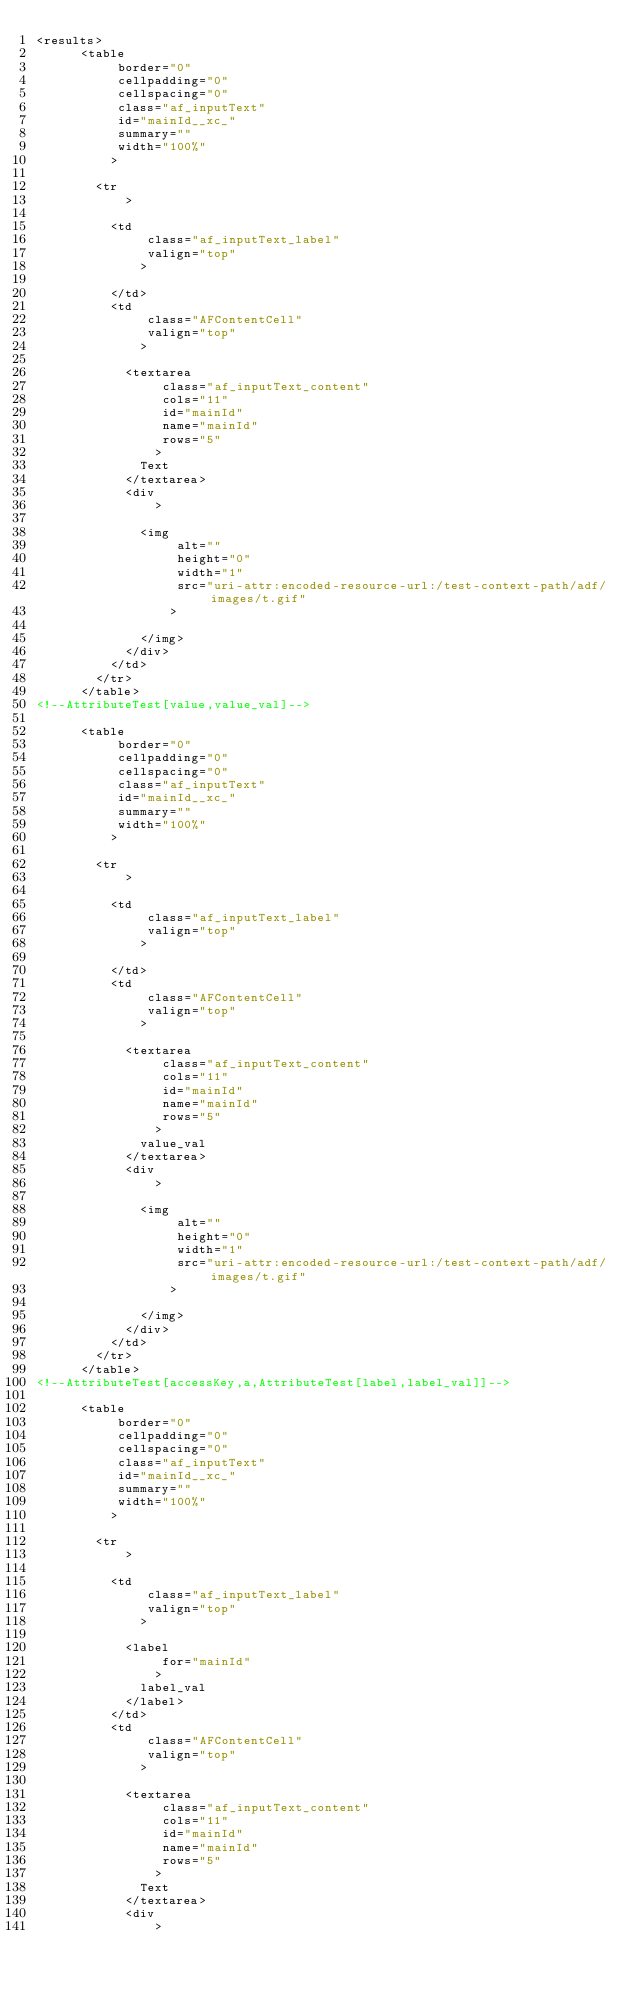Convert code to text. <code><loc_0><loc_0><loc_500><loc_500><_XML_><results>
      <table
           border="0"
           cellpadding="0"
           cellspacing="0"
           class="af_inputText"
           id="mainId__xc_"
           summary=""
           width="100%"
          >
        
        <tr
            >
          
          <td
               class="af_inputText_label"
               valign="top"
              >
            
          </td>
          <td
               class="AFContentCell"
               valign="top"
              >
            
            <textarea
                 class="af_inputText_content"
                 cols="11"
                 id="mainId"
                 name="mainId"
                 rows="5"
                >
              Text
            </textarea>
            <div
                >
              
              <img
                   alt=""
                   height="0"
                   width="1"
                   src="uri-attr:encoded-resource-url:/test-context-path/adf/images/t.gif"
                  >
                
              </img>
            </div>
          </td>
        </tr>
      </table>
<!--AttributeTest[value,value_val]-->

      <table
           border="0"
           cellpadding="0"
           cellspacing="0"
           class="af_inputText"
           id="mainId__xc_"
           summary=""
           width="100%"
          >
        
        <tr
            >
          
          <td
               class="af_inputText_label"
               valign="top"
              >
            
          </td>
          <td
               class="AFContentCell"
               valign="top"
              >
            
            <textarea
                 class="af_inputText_content"
                 cols="11"
                 id="mainId"
                 name="mainId"
                 rows="5"
                >
              value_val
            </textarea>
            <div
                >
              
              <img
                   alt=""
                   height="0"
                   width="1"
                   src="uri-attr:encoded-resource-url:/test-context-path/adf/images/t.gif"
                  >
                
              </img>
            </div>
          </td>
        </tr>
      </table>
<!--AttributeTest[accessKey,a,AttributeTest[label,label_val]]-->

      <table
           border="0"
           cellpadding="0"
           cellspacing="0"
           class="af_inputText"
           id="mainId__xc_"
           summary=""
           width="100%"
          >
        
        <tr
            >
          
          <td
               class="af_inputText_label"
               valign="top"
              >
            
            <label
                 for="mainId"
                >
              label_val
            </label>
          </td>
          <td
               class="AFContentCell"
               valign="top"
              >
            
            <textarea
                 class="af_inputText_content"
                 cols="11"
                 id="mainId"
                 name="mainId"
                 rows="5"
                >
              Text
            </textarea>
            <div
                >
              </code> 